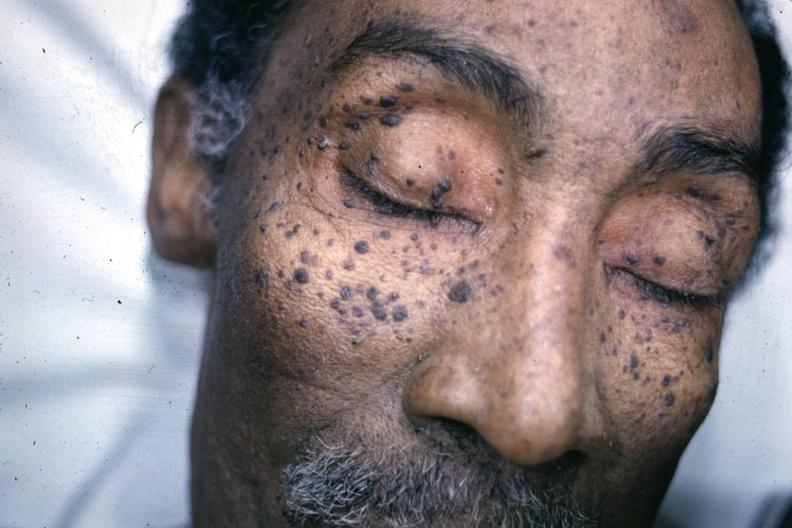does lymphoid atrophy in newborn show photo of face with multiple typical lesions?
Answer the question using a single word or phrase. No 